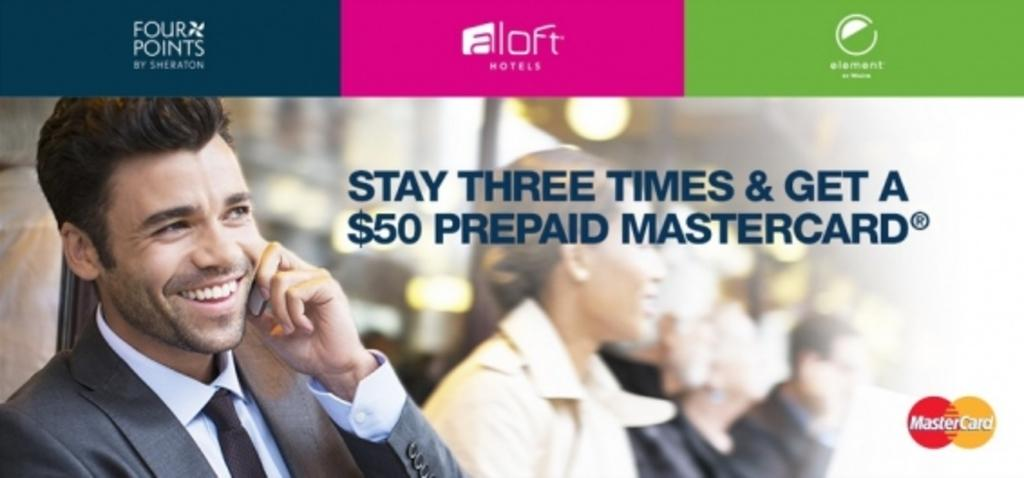What is the position of the man in the image? The man is on the left side of the image. What is the man's facial expression in the image? The man is smiling in the image. What object is the man holding in his hand? The man is holding a mobile in his hand. Are there any other people in the image? Yes, there are people next to the man in the image. What type of cast can be seen on the man's arm in the image? There is no cast visible on the man's arm in the image. Can you see a hook hanging from the man's belt in the image? There is no hook visible on the man's belt in the image. 